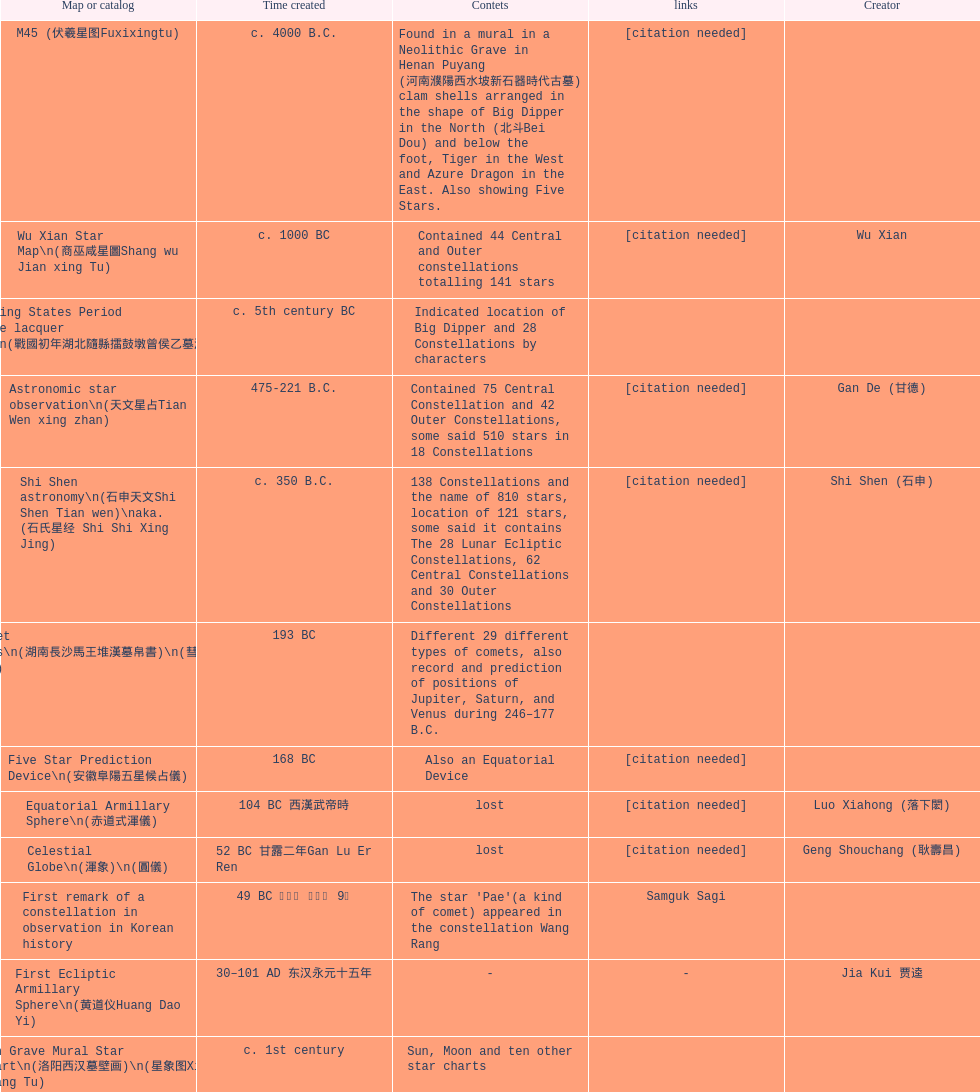What is the difference between the five star prediction device's date of creation and the han comet diagrams' date of creation? 25 years. 